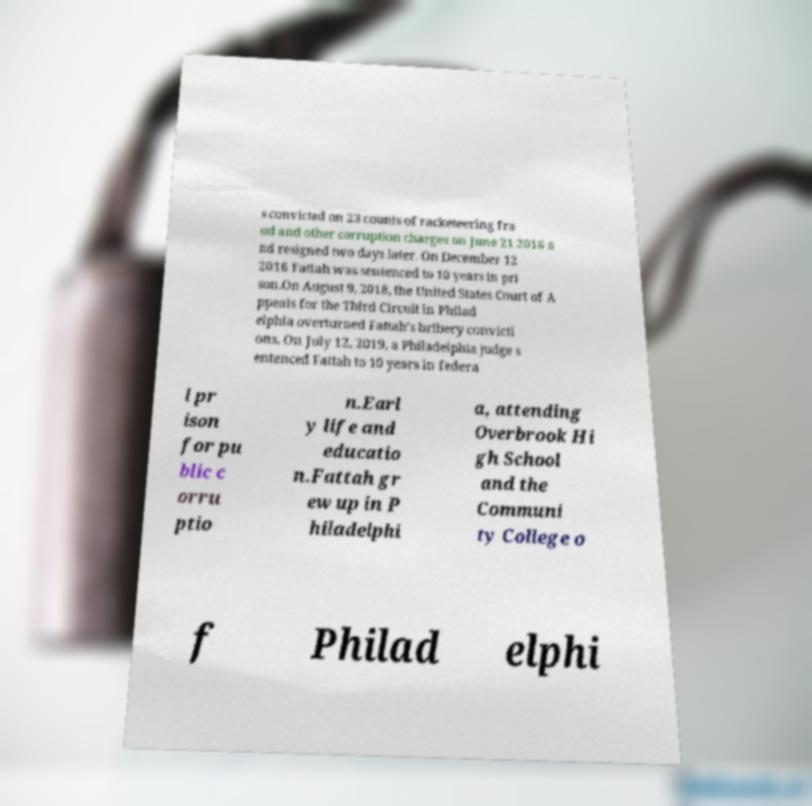Can you accurately transcribe the text from the provided image for me? s convicted on 23 counts of racketeering fra ud and other corruption charges on June 21 2016 a nd resigned two days later. On December 12 2016 Fattah was sentenced to 10 years in pri son.On August 9, 2018, the United States Court of A ppeals for the Third Circuit in Philad elphia overturned Fattah's bribery convicti ons. On July 12, 2019, a Philadelphia judge s entenced Fattah to 10 years in federa l pr ison for pu blic c orru ptio n.Earl y life and educatio n.Fattah gr ew up in P hiladelphi a, attending Overbrook Hi gh School and the Communi ty College o f Philad elphi 